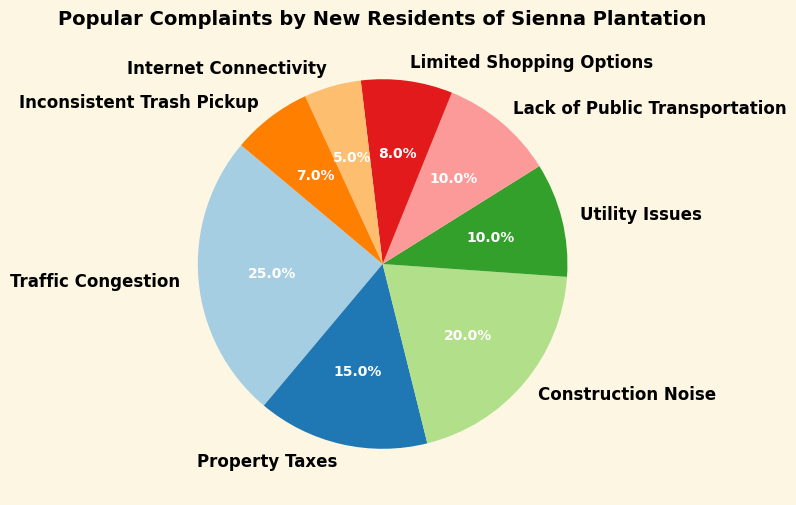Which complaint has the highest percentage among new residents of Sienna Plantation? The pie chart displays different complaints and their corresponding percentages. The segment labeled "Traffic Congestion" is the largest with a percentage of 25%.
Answer: Traffic Congestion What is the total percentage of complaints related to infrastructure (Traffic Congestion, Construction Noise, Utility Issues, Lack of Public Transportation)? To find the total percentage for infrastructure complaints, sum the individual percentages: 25 (Traffic Congestion) + 20 (Construction Noise) + 10 (Utility Issues) + 10 (Lack of Public Transportation). The sum is 65%.
Answer: 65% How does the percentage of complaints about Property Taxes compare to those about Inconsistent Trash Pickup? Property Taxes complaints are at 15%, whereas Inconsistent Trash Pickup complaints are at 7%. Therefore, Property Taxes complaints are greater.
Answer: Property Taxes complaints are greater Which complaint has the smallest percentage, and what is that percentage? By observing the pie chart, the segment representing Internet Connectivity is the smallest at 5%.
Answer: Internet Connectivity, 5% Are the complaints about Limited Shopping Options and Utility Issues equal? The pie chart shows that the complaint percentages for Limited Shopping Options and Utility Issues are different. Limited Shopping Options is 8%, and Utility Issues is 10%. Therefore, they are not equal.
Answer: No, they are not equal What is the percentage difference between Construction Noise and Property Taxes complaints? The percentage for Construction Noise is 20% and for Property Taxes is 15%. The difference is 20 - 15 = 5%.
Answer: 5% If a new resident were to select a random complaint from the chart, what is the probability that it would be either a Utility Issue or Lack of Public Transportation complaint? The percentages for Utility Issues and Lack of Public Transportation are both 10%. The probability is the combined percentage, 10 + 10 = 20%.
Answer: 20% Which two complaints have percentages that add up to 17%? The complaints with percentages that sum to 17% are Limited Shopping Options (8%) and Inconsistent Trash Pickup (7%); 8 + 7 = 15%.
Answer: None, no complaints add up to 17% 